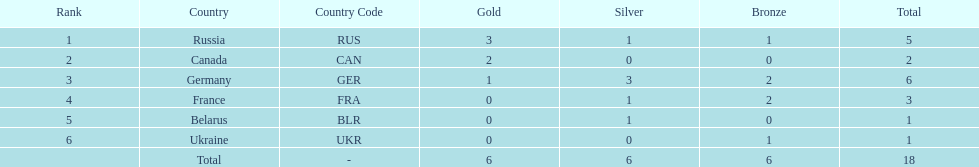What country had the most medals total at the the 1994 winter olympics biathlon? Germany (GER). 